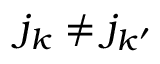<formula> <loc_0><loc_0><loc_500><loc_500>j _ { k } \ne j _ { k ^ { \prime } }</formula> 